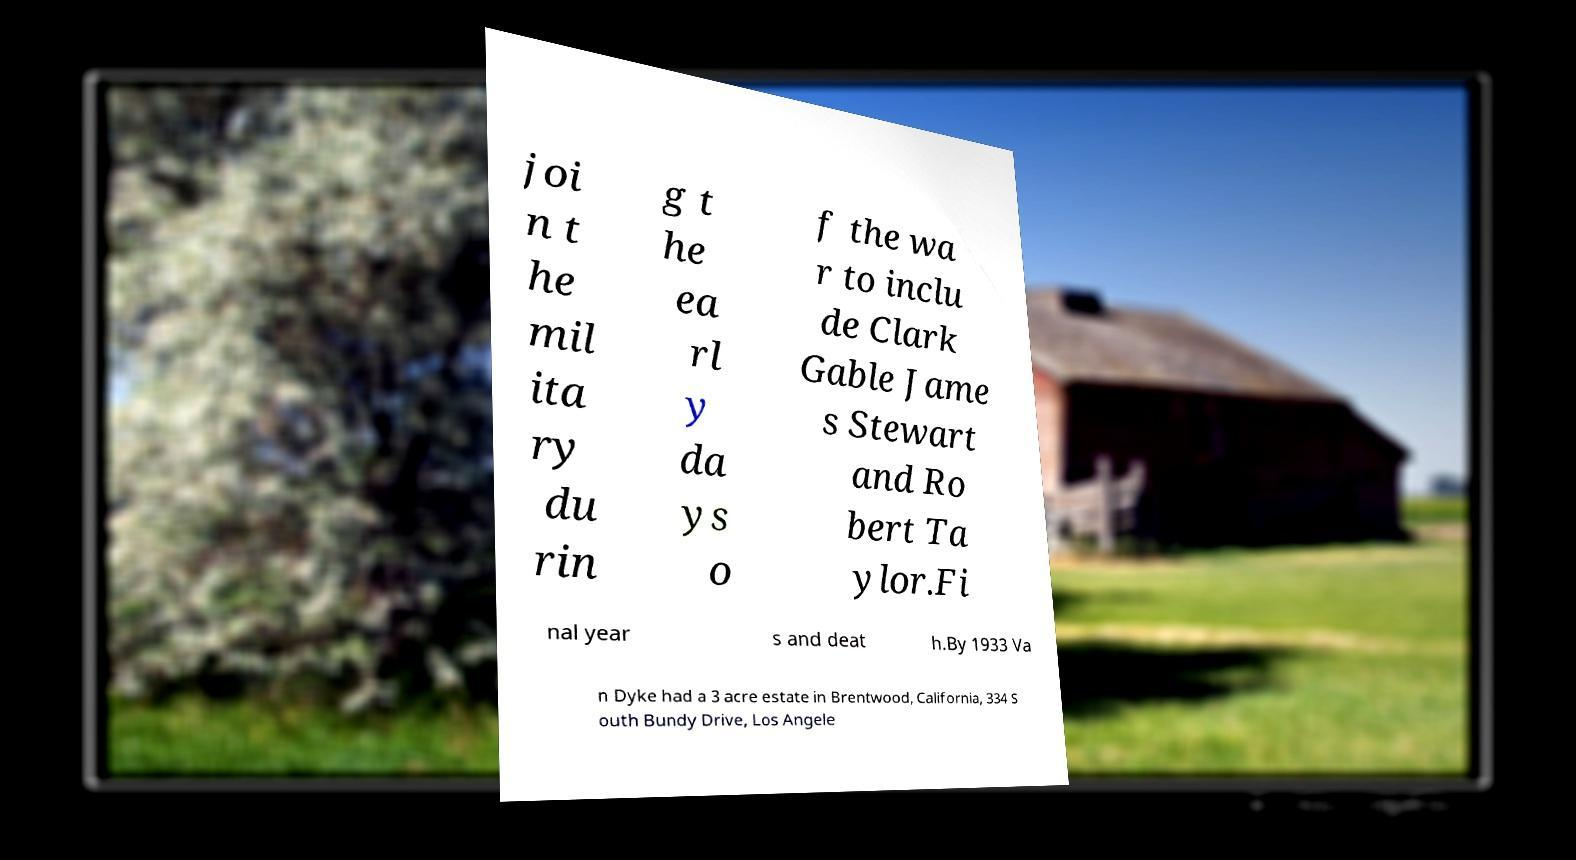Please identify and transcribe the text found in this image. joi n t he mil ita ry du rin g t he ea rl y da ys o f the wa r to inclu de Clark Gable Jame s Stewart and Ro bert Ta ylor.Fi nal year s and deat h.By 1933 Va n Dyke had a 3 acre estate in Brentwood, California, 334 S outh Bundy Drive, Los Angele 